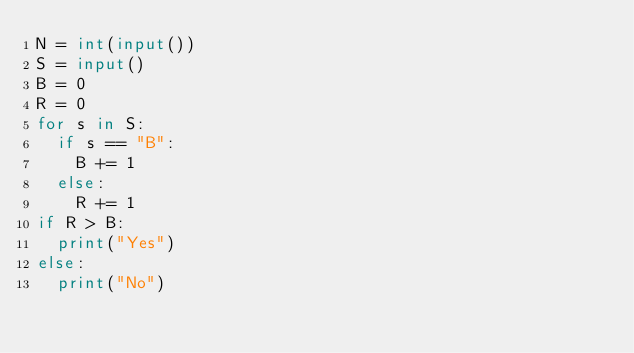Convert code to text. <code><loc_0><loc_0><loc_500><loc_500><_Python_>N = int(input())
S = input()
B = 0
R = 0
for s in S:
  if s == "B":
    B += 1
  else:
    R += 1
if R > B:
  print("Yes")
else:
  print("No")</code> 